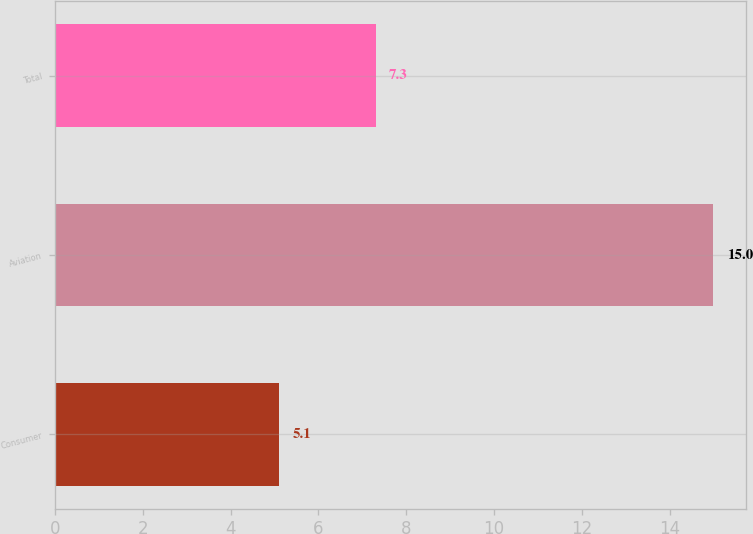<chart> <loc_0><loc_0><loc_500><loc_500><bar_chart><fcel>Consumer<fcel>Aviation<fcel>Total<nl><fcel>5.1<fcel>15<fcel>7.3<nl></chart> 